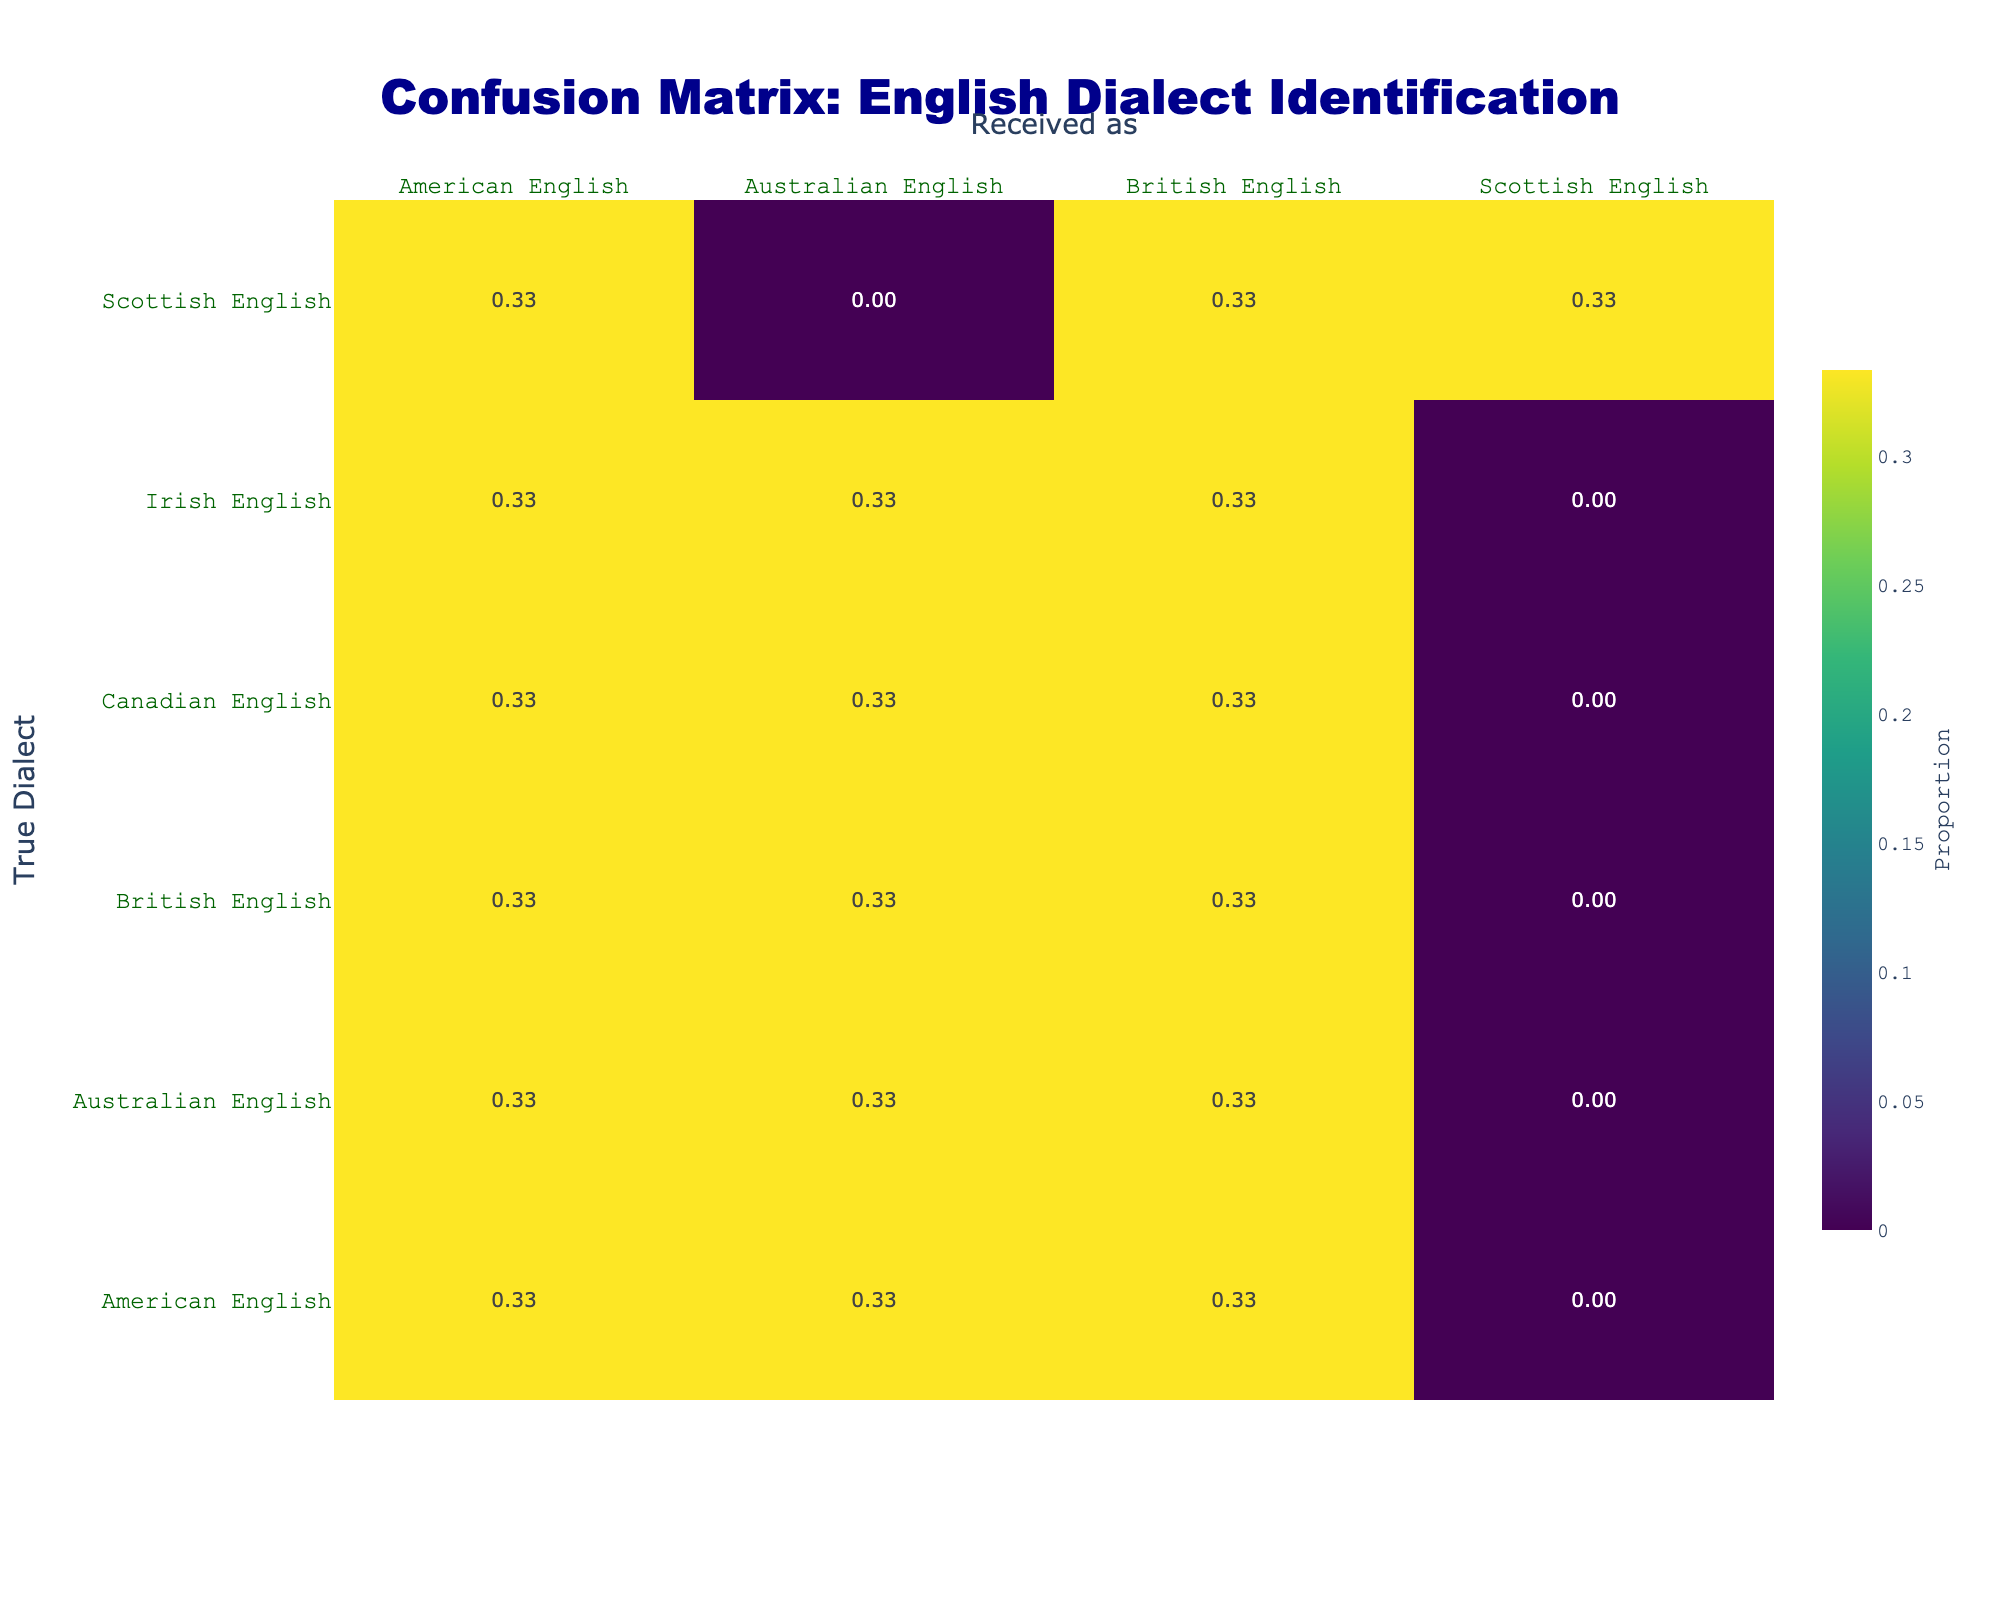What percentage of American English instances were correctly identified as American English? The total instances of American English are 4 (correctly identified as American English) out of 10 total instances (American English, British English, Australian English, Canadian English, Scottish English, Irish English). The percentage is calculated as (4/10) * 100 = 40%.
Answer: 40% What is the total number of instances of Australian English received as each dialect? The instances of Australian English received as American English, British English, and Australian English are 2, 1, and 3, respectively. So the total is 2 + 1 + 3 = 6.
Answer: 6 Did the model correctly identify more instances of British English than Australian English? From the table, British English was correctly identified 2 times, and Australian English was correctly identified 3 times. Therefore, the answer is false.
Answer: False What is the ratio of correctly identified Canadian English to incorrectly identified Canadian English? The correctly identified Canadian English is 1 (British English), and there are 2 incorrect identifications (Australian English, American English). The ratio is 1:2.
Answer: 1:2 What percentage of instances were incorrectly classified as British English? The total instances received as British English are 2 (false identifications) and 2 (correct identifications), giving 4 instances total. The incorrect identification percentage is calculated as (2/4) * 100 = 50%.
Answer: 50% How many dialects were misidentified as American English? The instances of dialects misidentified as American English include 1 from British English, 1 from Australian English, and 1 from Canadian English, totaling 3.
Answer: 3 What is the average proportion of correct identifications across all dialects? To find the average, add the correctly identified proportions: American (0.4) + British (0.5) + Australian (0.6) + Canadian (0.33) + Scottish (0.67) + Irish (0.33) = 3.8. Dividing by 6 dialects gives an average proportion of 3.8 / 6 = 0.633, or approximately 63.3%.
Answer: 63.3% How many total instances of English dialects were represented in the confusion matrix? The total number of instances can be found by counting all the rows and columns combined, which gives 18 instances when counting each unique label in the "Received as" column.
Answer: 18 